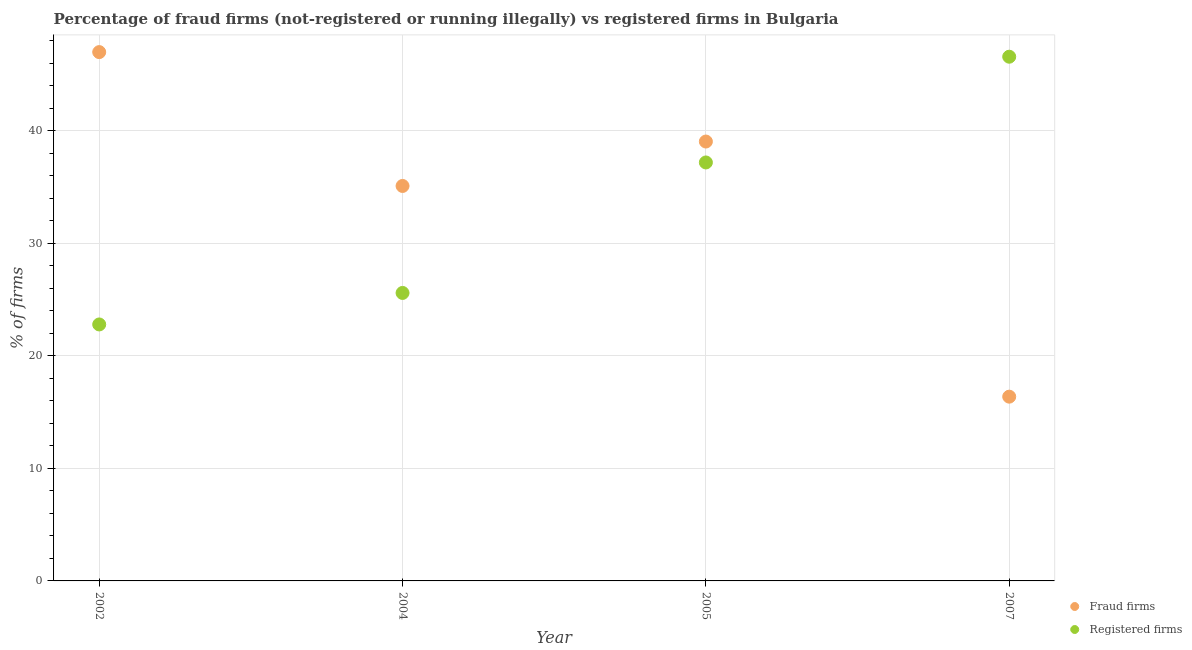What is the percentage of fraud firms in 2007?
Offer a terse response. 16.38. Across all years, what is the maximum percentage of fraud firms?
Ensure brevity in your answer.  47.01. Across all years, what is the minimum percentage of registered firms?
Ensure brevity in your answer.  22.8. What is the total percentage of fraud firms in the graph?
Offer a very short reply. 137.56. What is the difference between the percentage of registered firms in 2002 and that in 2005?
Provide a short and direct response. -14.4. What is the difference between the percentage of fraud firms in 2002 and the percentage of registered firms in 2004?
Keep it short and to the point. 21.41. What is the average percentage of fraud firms per year?
Keep it short and to the point. 34.39. In the year 2007, what is the difference between the percentage of fraud firms and percentage of registered firms?
Provide a short and direct response. -30.22. What is the ratio of the percentage of registered firms in 2002 to that in 2007?
Provide a succinct answer. 0.49. What is the difference between the highest and the second highest percentage of registered firms?
Your response must be concise. 9.4. What is the difference between the highest and the lowest percentage of fraud firms?
Provide a succinct answer. 30.63. In how many years, is the percentage of fraud firms greater than the average percentage of fraud firms taken over all years?
Your answer should be very brief. 3. Is the sum of the percentage of registered firms in 2002 and 2004 greater than the maximum percentage of fraud firms across all years?
Your answer should be compact. Yes. Is the percentage of registered firms strictly less than the percentage of fraud firms over the years?
Make the answer very short. No. How many years are there in the graph?
Offer a terse response. 4. What is the difference between two consecutive major ticks on the Y-axis?
Ensure brevity in your answer.  10. Are the values on the major ticks of Y-axis written in scientific E-notation?
Offer a terse response. No. Does the graph contain any zero values?
Provide a succinct answer. No. Does the graph contain grids?
Provide a succinct answer. Yes. Where does the legend appear in the graph?
Provide a succinct answer. Bottom right. What is the title of the graph?
Offer a very short reply. Percentage of fraud firms (not-registered or running illegally) vs registered firms in Bulgaria. Does "Female labor force" appear as one of the legend labels in the graph?
Make the answer very short. No. What is the label or title of the Y-axis?
Your answer should be compact. % of firms. What is the % of firms in Fraud firms in 2002?
Your response must be concise. 47.01. What is the % of firms of Registered firms in 2002?
Ensure brevity in your answer.  22.8. What is the % of firms of Fraud firms in 2004?
Your answer should be compact. 35.11. What is the % of firms in Registered firms in 2004?
Provide a short and direct response. 25.6. What is the % of firms in Fraud firms in 2005?
Provide a succinct answer. 39.06. What is the % of firms in Registered firms in 2005?
Make the answer very short. 37.2. What is the % of firms in Fraud firms in 2007?
Provide a succinct answer. 16.38. What is the % of firms in Registered firms in 2007?
Provide a succinct answer. 46.6. Across all years, what is the maximum % of firms in Fraud firms?
Provide a succinct answer. 47.01. Across all years, what is the maximum % of firms in Registered firms?
Offer a very short reply. 46.6. Across all years, what is the minimum % of firms in Fraud firms?
Give a very brief answer. 16.38. Across all years, what is the minimum % of firms of Registered firms?
Provide a short and direct response. 22.8. What is the total % of firms in Fraud firms in the graph?
Offer a very short reply. 137.56. What is the total % of firms of Registered firms in the graph?
Provide a succinct answer. 132.2. What is the difference between the % of firms of Fraud firms in 2002 and that in 2004?
Offer a terse response. 11.9. What is the difference between the % of firms in Registered firms in 2002 and that in 2004?
Keep it short and to the point. -2.8. What is the difference between the % of firms in Fraud firms in 2002 and that in 2005?
Ensure brevity in your answer.  7.95. What is the difference between the % of firms in Registered firms in 2002 and that in 2005?
Provide a succinct answer. -14.4. What is the difference between the % of firms in Fraud firms in 2002 and that in 2007?
Your answer should be very brief. 30.63. What is the difference between the % of firms of Registered firms in 2002 and that in 2007?
Make the answer very short. -23.8. What is the difference between the % of firms of Fraud firms in 2004 and that in 2005?
Give a very brief answer. -3.95. What is the difference between the % of firms in Fraud firms in 2004 and that in 2007?
Your answer should be very brief. 18.73. What is the difference between the % of firms in Fraud firms in 2005 and that in 2007?
Provide a succinct answer. 22.68. What is the difference between the % of firms of Registered firms in 2005 and that in 2007?
Provide a succinct answer. -9.4. What is the difference between the % of firms in Fraud firms in 2002 and the % of firms in Registered firms in 2004?
Your response must be concise. 21.41. What is the difference between the % of firms in Fraud firms in 2002 and the % of firms in Registered firms in 2005?
Ensure brevity in your answer.  9.81. What is the difference between the % of firms in Fraud firms in 2002 and the % of firms in Registered firms in 2007?
Keep it short and to the point. 0.41. What is the difference between the % of firms in Fraud firms in 2004 and the % of firms in Registered firms in 2005?
Your answer should be compact. -2.09. What is the difference between the % of firms of Fraud firms in 2004 and the % of firms of Registered firms in 2007?
Offer a terse response. -11.49. What is the difference between the % of firms in Fraud firms in 2005 and the % of firms in Registered firms in 2007?
Provide a short and direct response. -7.54. What is the average % of firms of Fraud firms per year?
Provide a short and direct response. 34.39. What is the average % of firms of Registered firms per year?
Ensure brevity in your answer.  33.05. In the year 2002, what is the difference between the % of firms in Fraud firms and % of firms in Registered firms?
Offer a terse response. 24.21. In the year 2004, what is the difference between the % of firms in Fraud firms and % of firms in Registered firms?
Keep it short and to the point. 9.51. In the year 2005, what is the difference between the % of firms of Fraud firms and % of firms of Registered firms?
Keep it short and to the point. 1.86. In the year 2007, what is the difference between the % of firms in Fraud firms and % of firms in Registered firms?
Ensure brevity in your answer.  -30.22. What is the ratio of the % of firms of Fraud firms in 2002 to that in 2004?
Your answer should be very brief. 1.34. What is the ratio of the % of firms of Registered firms in 2002 to that in 2004?
Offer a terse response. 0.89. What is the ratio of the % of firms in Fraud firms in 2002 to that in 2005?
Your answer should be compact. 1.2. What is the ratio of the % of firms in Registered firms in 2002 to that in 2005?
Your answer should be compact. 0.61. What is the ratio of the % of firms of Fraud firms in 2002 to that in 2007?
Ensure brevity in your answer.  2.87. What is the ratio of the % of firms in Registered firms in 2002 to that in 2007?
Your response must be concise. 0.49. What is the ratio of the % of firms of Fraud firms in 2004 to that in 2005?
Provide a short and direct response. 0.9. What is the ratio of the % of firms of Registered firms in 2004 to that in 2005?
Offer a terse response. 0.69. What is the ratio of the % of firms of Fraud firms in 2004 to that in 2007?
Your answer should be compact. 2.14. What is the ratio of the % of firms in Registered firms in 2004 to that in 2007?
Ensure brevity in your answer.  0.55. What is the ratio of the % of firms in Fraud firms in 2005 to that in 2007?
Provide a succinct answer. 2.38. What is the ratio of the % of firms in Registered firms in 2005 to that in 2007?
Provide a succinct answer. 0.8. What is the difference between the highest and the second highest % of firms of Fraud firms?
Offer a very short reply. 7.95. What is the difference between the highest and the second highest % of firms of Registered firms?
Provide a short and direct response. 9.4. What is the difference between the highest and the lowest % of firms of Fraud firms?
Provide a short and direct response. 30.63. What is the difference between the highest and the lowest % of firms of Registered firms?
Provide a succinct answer. 23.8. 